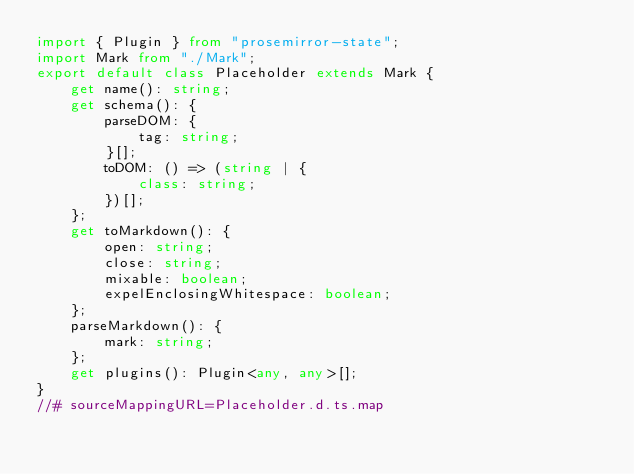Convert code to text. <code><loc_0><loc_0><loc_500><loc_500><_TypeScript_>import { Plugin } from "prosemirror-state";
import Mark from "./Mark";
export default class Placeholder extends Mark {
    get name(): string;
    get schema(): {
        parseDOM: {
            tag: string;
        }[];
        toDOM: () => (string | {
            class: string;
        })[];
    };
    get toMarkdown(): {
        open: string;
        close: string;
        mixable: boolean;
        expelEnclosingWhitespace: boolean;
    };
    parseMarkdown(): {
        mark: string;
    };
    get plugins(): Plugin<any, any>[];
}
//# sourceMappingURL=Placeholder.d.ts.map</code> 